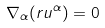Convert formula to latex. <formula><loc_0><loc_0><loc_500><loc_500>\nabla _ { \alpha } ( r u ^ { \alpha } ) = 0</formula> 